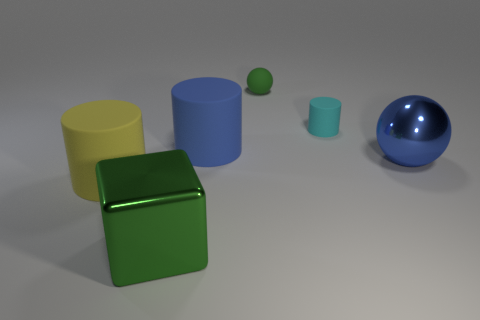Subtract all cyan blocks. Subtract all blue cylinders. How many blocks are left? 1 Add 3 large green metallic objects. How many objects exist? 9 Subtract all blocks. How many objects are left? 5 Subtract 0 green cylinders. How many objects are left? 6 Subtract all rubber cylinders. Subtract all big blue balls. How many objects are left? 2 Add 1 tiny cyan rubber cylinders. How many tiny cyan rubber cylinders are left? 2 Add 4 yellow cylinders. How many yellow cylinders exist? 5 